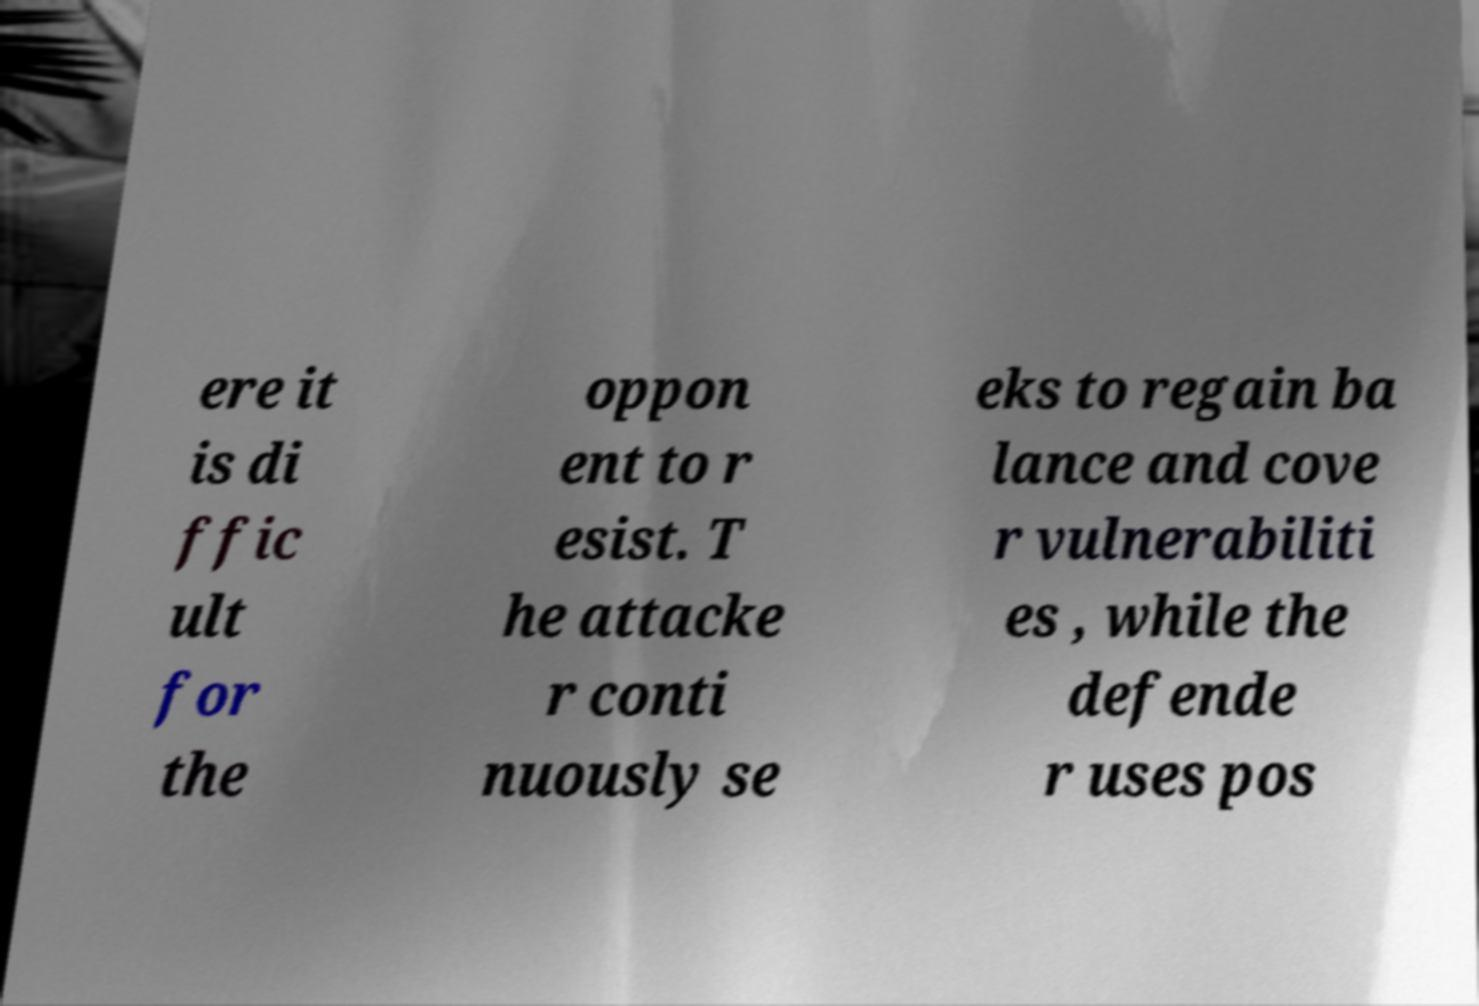There's text embedded in this image that I need extracted. Can you transcribe it verbatim? ere it is di ffic ult for the oppon ent to r esist. T he attacke r conti nuously se eks to regain ba lance and cove r vulnerabiliti es , while the defende r uses pos 